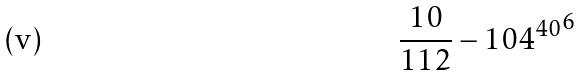Convert formula to latex. <formula><loc_0><loc_0><loc_500><loc_500>\frac { 1 0 } { 1 1 2 } - { 1 0 4 ^ { 4 0 } } ^ { 6 }</formula> 